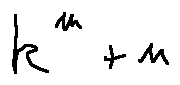<formula> <loc_0><loc_0><loc_500><loc_500>k ^ { m } + n</formula> 